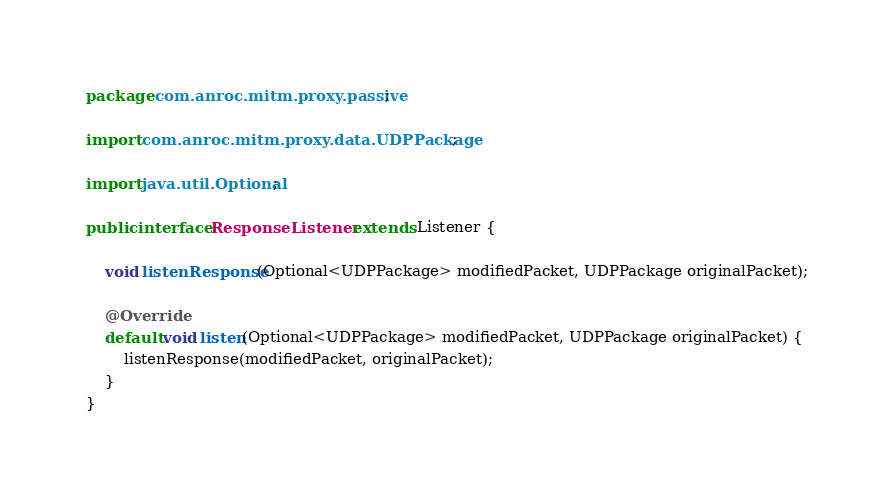<code> <loc_0><loc_0><loc_500><loc_500><_Java_>package com.anroc.mitm.proxy.passive;

import com.anroc.mitm.proxy.data.UDPPackage;

import java.util.Optional;

public interface ResponseListener extends Listener {

    void listenResponse(Optional<UDPPackage> modifiedPacket, UDPPackage originalPacket);

    @Override
    default void listen(Optional<UDPPackage> modifiedPacket, UDPPackage originalPacket) {
        listenResponse(modifiedPacket, originalPacket);
    }
}
</code> 